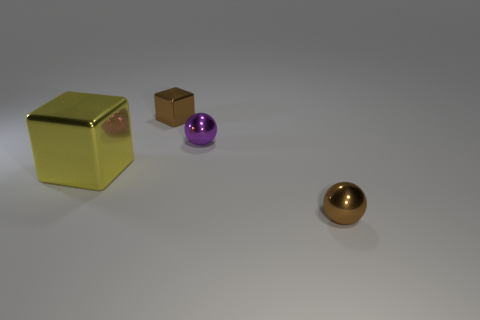Add 1 blocks. How many objects exist? 5 Subtract 0 gray cubes. How many objects are left? 4 Subtract all spheres. Subtract all purple things. How many objects are left? 1 Add 4 tiny purple things. How many tiny purple things are left? 5 Add 3 small green metallic objects. How many small green metallic objects exist? 3 